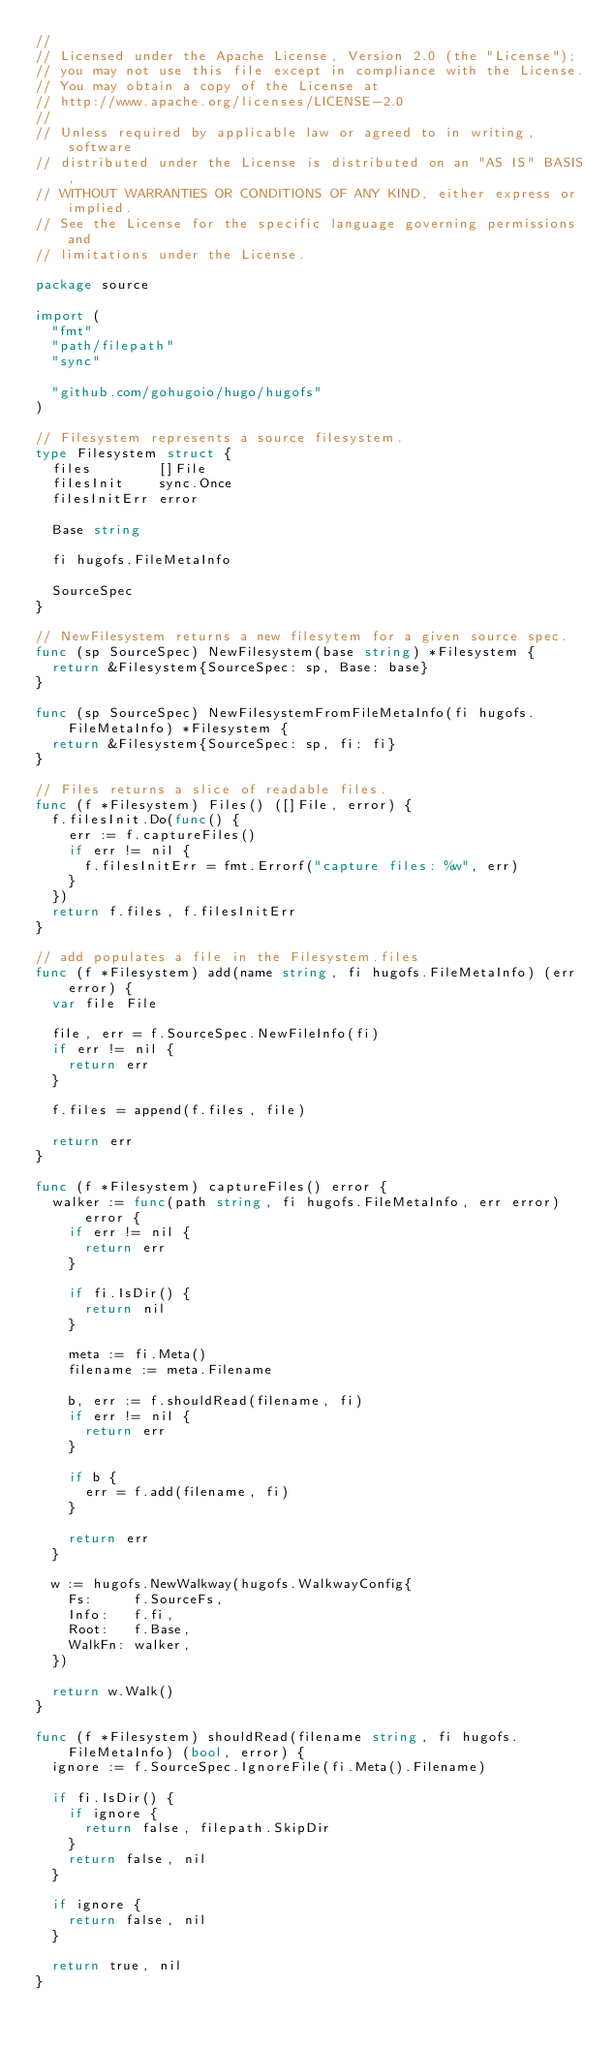<code> <loc_0><loc_0><loc_500><loc_500><_Go_>//
// Licensed under the Apache License, Version 2.0 (the "License");
// you may not use this file except in compliance with the License.
// You may obtain a copy of the License at
// http://www.apache.org/licenses/LICENSE-2.0
//
// Unless required by applicable law or agreed to in writing, software
// distributed under the License is distributed on an "AS IS" BASIS,
// WITHOUT WARRANTIES OR CONDITIONS OF ANY KIND, either express or implied.
// See the License for the specific language governing permissions and
// limitations under the License.

package source

import (
	"fmt"
	"path/filepath"
	"sync"

	"github.com/gohugoio/hugo/hugofs"
)

// Filesystem represents a source filesystem.
type Filesystem struct {
	files        []File
	filesInit    sync.Once
	filesInitErr error

	Base string

	fi hugofs.FileMetaInfo

	SourceSpec
}

// NewFilesystem returns a new filesytem for a given source spec.
func (sp SourceSpec) NewFilesystem(base string) *Filesystem {
	return &Filesystem{SourceSpec: sp, Base: base}
}

func (sp SourceSpec) NewFilesystemFromFileMetaInfo(fi hugofs.FileMetaInfo) *Filesystem {
	return &Filesystem{SourceSpec: sp, fi: fi}
}

// Files returns a slice of readable files.
func (f *Filesystem) Files() ([]File, error) {
	f.filesInit.Do(func() {
		err := f.captureFiles()
		if err != nil {
			f.filesInitErr = fmt.Errorf("capture files: %w", err)
		}
	})
	return f.files, f.filesInitErr
}

// add populates a file in the Filesystem.files
func (f *Filesystem) add(name string, fi hugofs.FileMetaInfo) (err error) {
	var file File

	file, err = f.SourceSpec.NewFileInfo(fi)
	if err != nil {
		return err
	}

	f.files = append(f.files, file)

	return err
}

func (f *Filesystem) captureFiles() error {
	walker := func(path string, fi hugofs.FileMetaInfo, err error) error {
		if err != nil {
			return err
		}

		if fi.IsDir() {
			return nil
		}

		meta := fi.Meta()
		filename := meta.Filename

		b, err := f.shouldRead(filename, fi)
		if err != nil {
			return err
		}

		if b {
			err = f.add(filename, fi)
		}

		return err
	}

	w := hugofs.NewWalkway(hugofs.WalkwayConfig{
		Fs:     f.SourceFs,
		Info:   f.fi,
		Root:   f.Base,
		WalkFn: walker,
	})

	return w.Walk()
}

func (f *Filesystem) shouldRead(filename string, fi hugofs.FileMetaInfo) (bool, error) {
	ignore := f.SourceSpec.IgnoreFile(fi.Meta().Filename)

	if fi.IsDir() {
		if ignore {
			return false, filepath.SkipDir
		}
		return false, nil
	}

	if ignore {
		return false, nil
	}

	return true, nil
}
</code> 